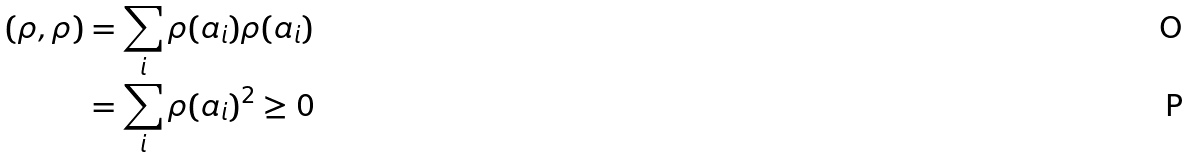<formula> <loc_0><loc_0><loc_500><loc_500>( \rho , \rho ) & = \sum _ { i } \rho ( a _ { i } ) \rho ( a _ { i } ) \\ & = \sum _ { i } \rho ( a _ { i } ) ^ { 2 } \geq 0</formula> 